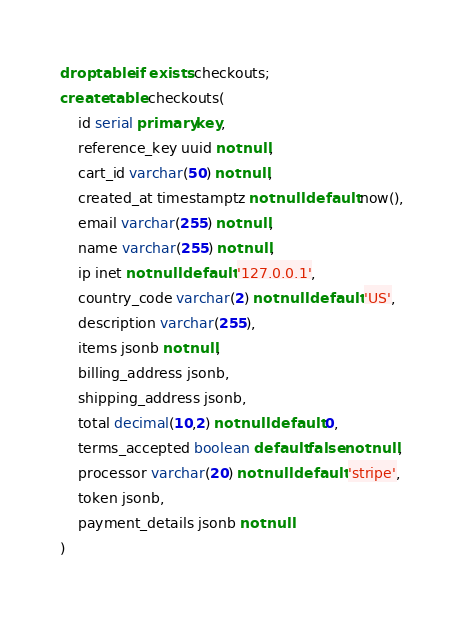<code> <loc_0><loc_0><loc_500><loc_500><_SQL_>drop table if exists checkouts;
create table checkouts(
	id serial primary key,
	reference_key uuid not null,
	cart_id varchar(50) not null,
	created_at timestamptz not null default now(),
	email varchar(255) not null,
	name varchar(255) not null,
	ip inet not null default '127.0.0.1',
	country_code varchar(2) not null default 'US',
	description varchar(255),
	items jsonb not null,
	billing_address jsonb,
	shipping_address jsonb,
	total decimal(10,2) not null default 0,
	terms_accepted boolean default false not null,
	processor varchar(20) not null default 'stripe',
	token jsonb,
	payment_details jsonb not null
)
</code> 